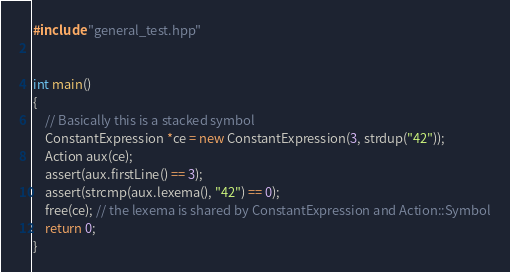<code> <loc_0><loc_0><loc_500><loc_500><_C++_>#include "general_test.hpp"


int main()
{
	// Basically this is a stacked symbol
	ConstantExpression *ce = new ConstantExpression(3, strdup("42"));
	Action aux(ce);
	assert(aux.firstLine() == 3);
	assert(strcmp(aux.lexema(), "42") == 0);
	free(ce); // the lexema is shared by ConstantExpression and Action::Symbol
	return 0;
}
</code> 